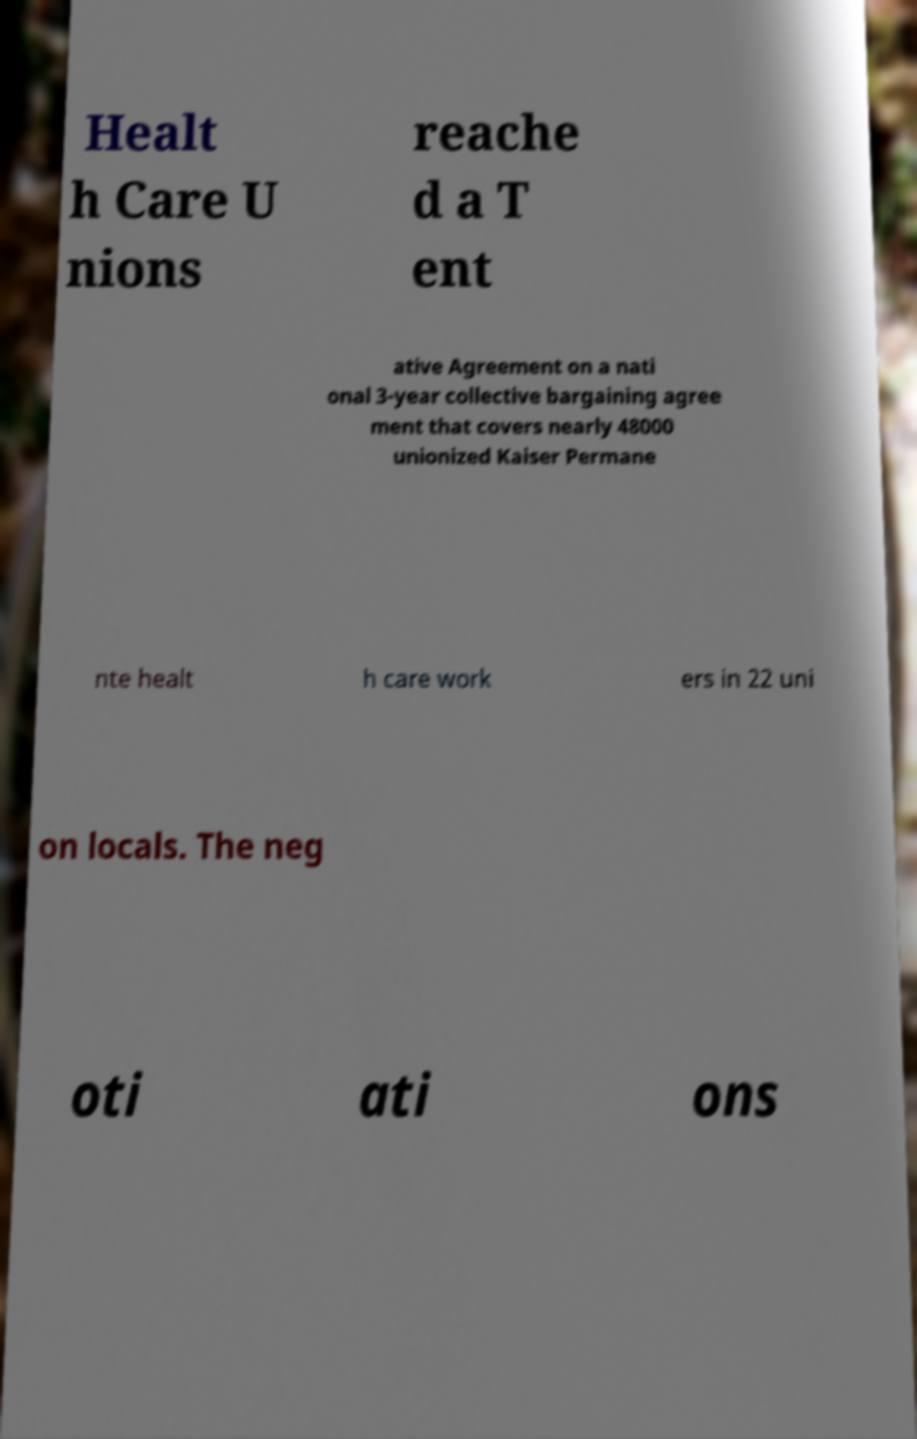Can you accurately transcribe the text from the provided image for me? Healt h Care U nions reache d a T ent ative Agreement on a nati onal 3-year collective bargaining agree ment that covers nearly 48000 unionized Kaiser Permane nte healt h care work ers in 22 uni on locals. The neg oti ati ons 